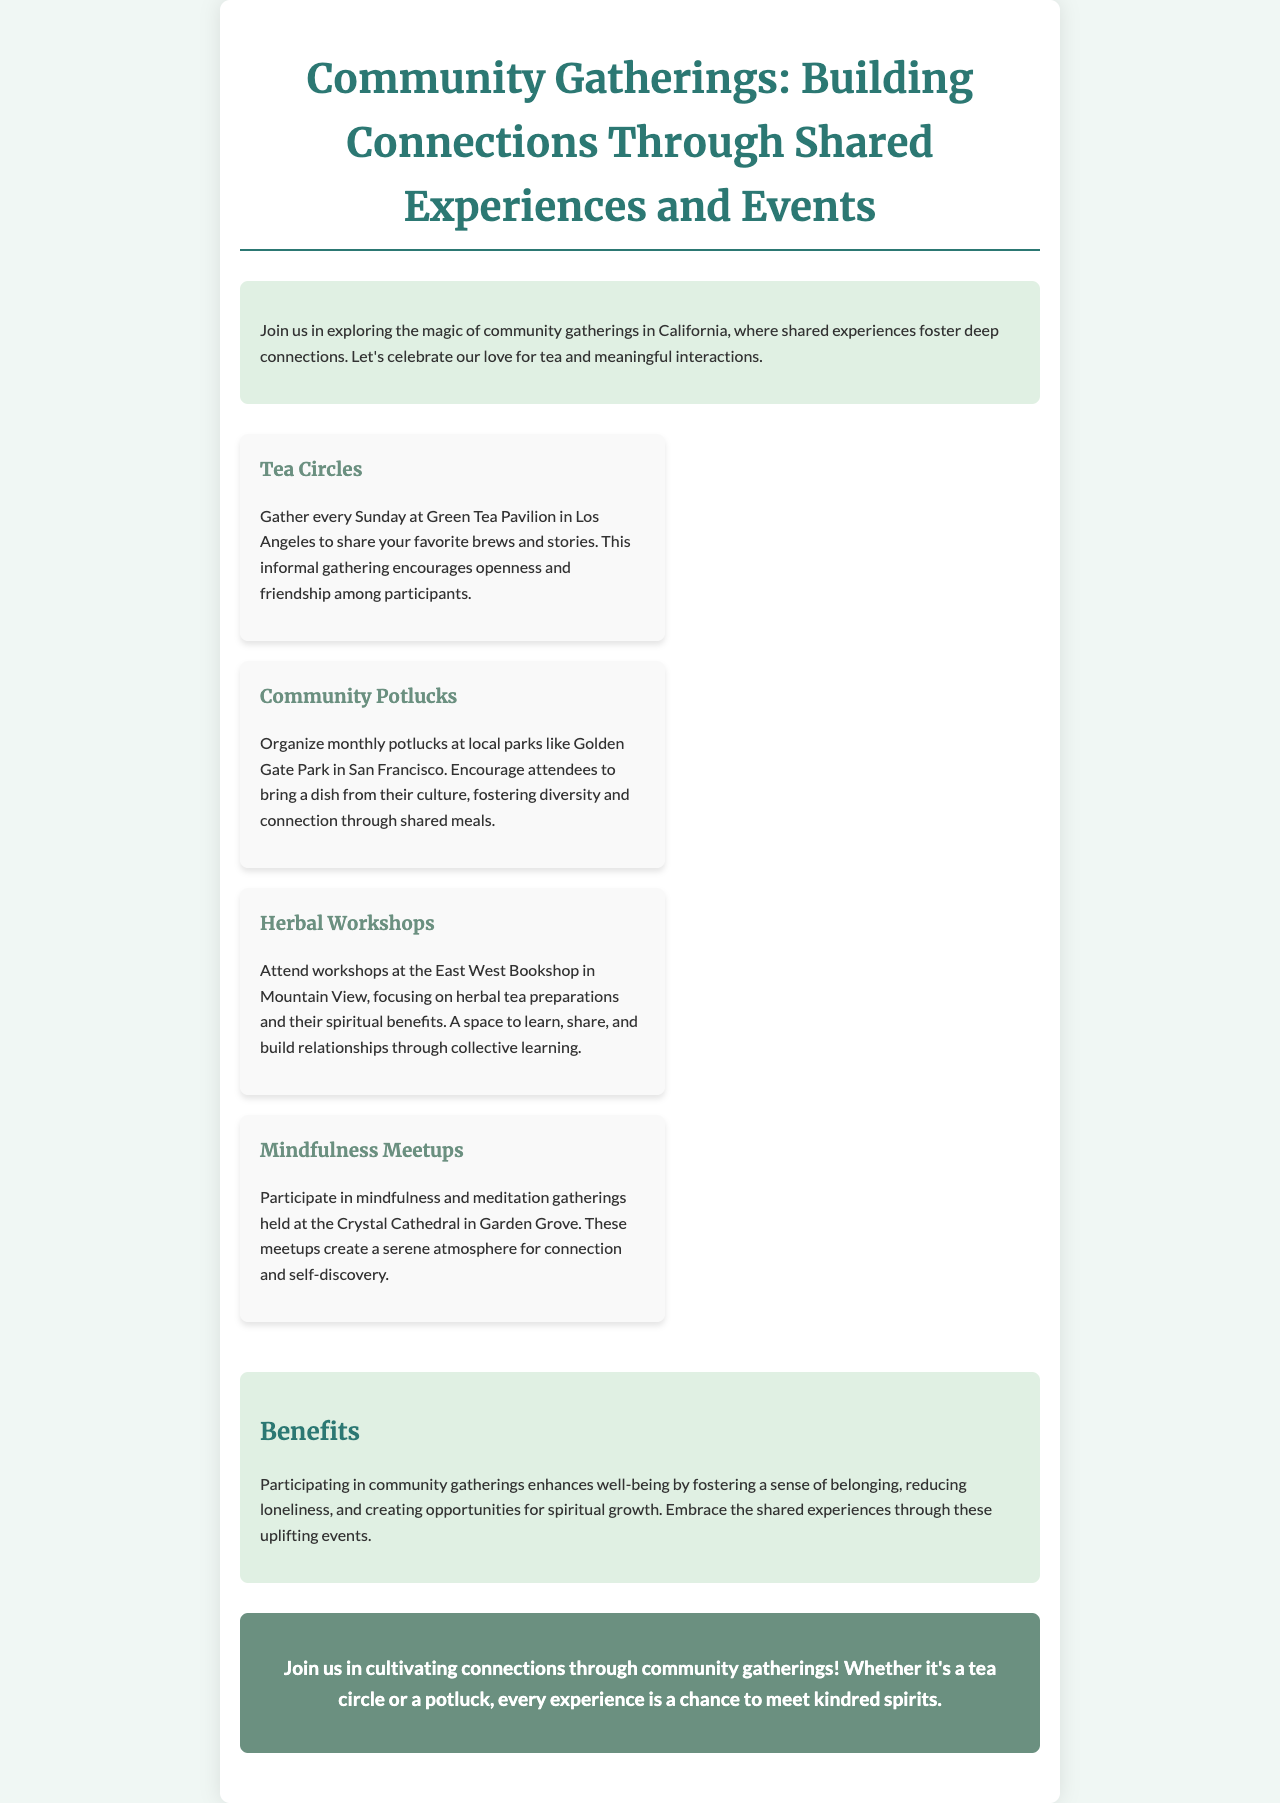what is the title of the brochure? The title summarizes the main theme of the document, which is focused on community gatherings.
Answer: Community Gatherings: Building Connections Through Shared Experiences and Events what day do the Tea Circles take place? The specific schedule for the Tea Circles is mentioned in the document.
Answer: Sunday where do the Community Potlucks occur? The location specified for the potlucks indicates where the gatherings are held.
Answer: Golden Gate Park what type of atmosphere do Mindfulness Meetups create? The document describes the ambiance of the meetups in a way that reflects their purpose.
Answer: serene what can participants learn about at Herbal Workshops? The content of the workshops is highlighted in the document, indicating what attendees will be educated on.
Answer: herbal tea preparations how often are the potlucks organized? The frequency of the potlucks is stated directly in the document.
Answer: monthly what color is used for heading text in the brochure? The document notes the color scheme associated with headings, providing a visual detail.
Answer: #2c7873 what are the benefits of participating in community gatherings? The document outlines some of the advantages of being part of these gatherings, summarizing their impact.
Answer: enhances well-being 